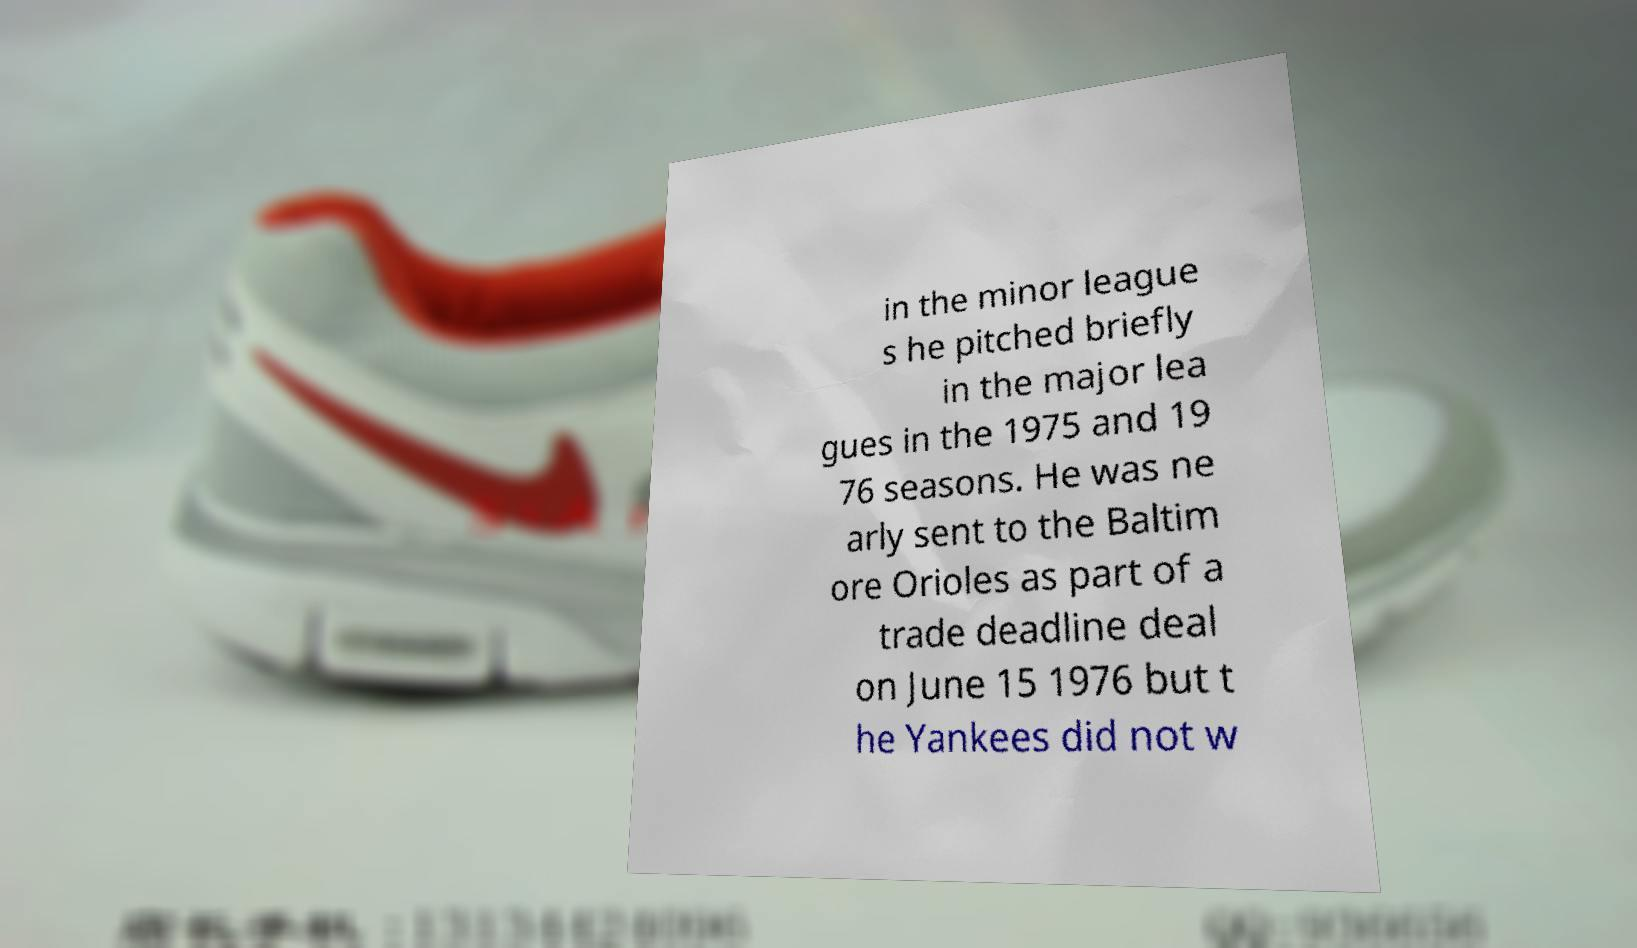Could you extract and type out the text from this image? in the minor league s he pitched briefly in the major lea gues in the 1975 and 19 76 seasons. He was ne arly sent to the Baltim ore Orioles as part of a trade deadline deal on June 15 1976 but t he Yankees did not w 